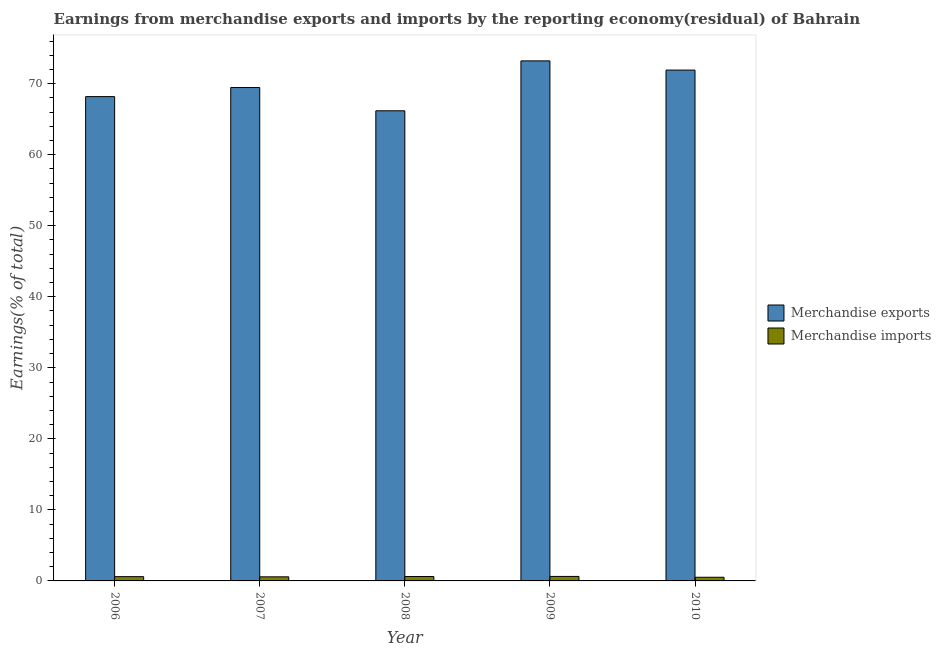How many different coloured bars are there?
Offer a terse response. 2. Are the number of bars on each tick of the X-axis equal?
Provide a succinct answer. Yes. How many bars are there on the 2nd tick from the left?
Provide a short and direct response. 2. In how many cases, is the number of bars for a given year not equal to the number of legend labels?
Your answer should be compact. 0. What is the earnings from merchandise imports in 2010?
Offer a very short reply. 0.52. Across all years, what is the maximum earnings from merchandise exports?
Offer a terse response. 73.21. Across all years, what is the minimum earnings from merchandise imports?
Your response must be concise. 0.52. In which year was the earnings from merchandise exports maximum?
Offer a terse response. 2009. What is the total earnings from merchandise exports in the graph?
Keep it short and to the point. 348.96. What is the difference between the earnings from merchandise imports in 2006 and that in 2009?
Offer a terse response. -0.03. What is the difference between the earnings from merchandise exports in 2006 and the earnings from merchandise imports in 2007?
Give a very brief answer. -1.28. What is the average earnings from merchandise exports per year?
Your answer should be very brief. 69.79. What is the ratio of the earnings from merchandise imports in 2008 to that in 2009?
Provide a short and direct response. 0.98. Is the difference between the earnings from merchandise imports in 2006 and 2007 greater than the difference between the earnings from merchandise exports in 2006 and 2007?
Offer a very short reply. No. What is the difference between the highest and the second highest earnings from merchandise imports?
Give a very brief answer. 0.01. What is the difference between the highest and the lowest earnings from merchandise imports?
Make the answer very short. 0.12. In how many years, is the earnings from merchandise imports greater than the average earnings from merchandise imports taken over all years?
Provide a short and direct response. 3. What does the 1st bar from the right in 2008 represents?
Keep it short and to the point. Merchandise imports. Are all the bars in the graph horizontal?
Ensure brevity in your answer.  No. Does the graph contain any zero values?
Make the answer very short. No. How are the legend labels stacked?
Give a very brief answer. Vertical. What is the title of the graph?
Your answer should be very brief. Earnings from merchandise exports and imports by the reporting economy(residual) of Bahrain. Does "Imports" appear as one of the legend labels in the graph?
Offer a very short reply. No. What is the label or title of the Y-axis?
Ensure brevity in your answer.  Earnings(% of total). What is the Earnings(% of total) of Merchandise exports in 2006?
Ensure brevity in your answer.  68.18. What is the Earnings(% of total) in Merchandise imports in 2006?
Offer a very short reply. 0.6. What is the Earnings(% of total) in Merchandise exports in 2007?
Offer a very short reply. 69.46. What is the Earnings(% of total) in Merchandise imports in 2007?
Ensure brevity in your answer.  0.58. What is the Earnings(% of total) in Merchandise exports in 2008?
Your answer should be compact. 66.19. What is the Earnings(% of total) of Merchandise imports in 2008?
Make the answer very short. 0.62. What is the Earnings(% of total) in Merchandise exports in 2009?
Make the answer very short. 73.21. What is the Earnings(% of total) in Merchandise imports in 2009?
Keep it short and to the point. 0.63. What is the Earnings(% of total) of Merchandise exports in 2010?
Offer a terse response. 71.92. What is the Earnings(% of total) of Merchandise imports in 2010?
Provide a succinct answer. 0.52. Across all years, what is the maximum Earnings(% of total) in Merchandise exports?
Make the answer very short. 73.21. Across all years, what is the maximum Earnings(% of total) in Merchandise imports?
Your answer should be very brief. 0.63. Across all years, what is the minimum Earnings(% of total) in Merchandise exports?
Your answer should be very brief. 66.19. Across all years, what is the minimum Earnings(% of total) of Merchandise imports?
Provide a succinct answer. 0.52. What is the total Earnings(% of total) in Merchandise exports in the graph?
Your answer should be compact. 348.96. What is the total Earnings(% of total) of Merchandise imports in the graph?
Offer a very short reply. 2.94. What is the difference between the Earnings(% of total) in Merchandise exports in 2006 and that in 2007?
Offer a terse response. -1.28. What is the difference between the Earnings(% of total) of Merchandise imports in 2006 and that in 2007?
Your answer should be compact. 0.03. What is the difference between the Earnings(% of total) in Merchandise exports in 2006 and that in 2008?
Your answer should be very brief. 2. What is the difference between the Earnings(% of total) of Merchandise imports in 2006 and that in 2008?
Offer a very short reply. -0.02. What is the difference between the Earnings(% of total) in Merchandise exports in 2006 and that in 2009?
Make the answer very short. -5.03. What is the difference between the Earnings(% of total) of Merchandise imports in 2006 and that in 2009?
Your answer should be compact. -0.03. What is the difference between the Earnings(% of total) in Merchandise exports in 2006 and that in 2010?
Give a very brief answer. -3.74. What is the difference between the Earnings(% of total) of Merchandise imports in 2006 and that in 2010?
Your answer should be compact. 0.09. What is the difference between the Earnings(% of total) in Merchandise exports in 2007 and that in 2008?
Offer a very short reply. 3.27. What is the difference between the Earnings(% of total) in Merchandise imports in 2007 and that in 2008?
Offer a very short reply. -0.04. What is the difference between the Earnings(% of total) in Merchandise exports in 2007 and that in 2009?
Ensure brevity in your answer.  -3.75. What is the difference between the Earnings(% of total) of Merchandise imports in 2007 and that in 2009?
Ensure brevity in your answer.  -0.06. What is the difference between the Earnings(% of total) of Merchandise exports in 2007 and that in 2010?
Provide a succinct answer. -2.46. What is the difference between the Earnings(% of total) in Merchandise imports in 2007 and that in 2010?
Offer a terse response. 0.06. What is the difference between the Earnings(% of total) in Merchandise exports in 2008 and that in 2009?
Provide a succinct answer. -7.03. What is the difference between the Earnings(% of total) of Merchandise imports in 2008 and that in 2009?
Provide a short and direct response. -0.01. What is the difference between the Earnings(% of total) of Merchandise exports in 2008 and that in 2010?
Your response must be concise. -5.73. What is the difference between the Earnings(% of total) of Merchandise imports in 2008 and that in 2010?
Keep it short and to the point. 0.1. What is the difference between the Earnings(% of total) of Merchandise exports in 2009 and that in 2010?
Offer a terse response. 1.3. What is the difference between the Earnings(% of total) in Merchandise imports in 2009 and that in 2010?
Provide a short and direct response. 0.12. What is the difference between the Earnings(% of total) in Merchandise exports in 2006 and the Earnings(% of total) in Merchandise imports in 2007?
Provide a succinct answer. 67.61. What is the difference between the Earnings(% of total) of Merchandise exports in 2006 and the Earnings(% of total) of Merchandise imports in 2008?
Offer a very short reply. 67.56. What is the difference between the Earnings(% of total) in Merchandise exports in 2006 and the Earnings(% of total) in Merchandise imports in 2009?
Offer a very short reply. 67.55. What is the difference between the Earnings(% of total) in Merchandise exports in 2006 and the Earnings(% of total) in Merchandise imports in 2010?
Your answer should be compact. 67.67. What is the difference between the Earnings(% of total) in Merchandise exports in 2007 and the Earnings(% of total) in Merchandise imports in 2008?
Your answer should be very brief. 68.84. What is the difference between the Earnings(% of total) in Merchandise exports in 2007 and the Earnings(% of total) in Merchandise imports in 2009?
Your response must be concise. 68.83. What is the difference between the Earnings(% of total) of Merchandise exports in 2007 and the Earnings(% of total) of Merchandise imports in 2010?
Ensure brevity in your answer.  68.94. What is the difference between the Earnings(% of total) in Merchandise exports in 2008 and the Earnings(% of total) in Merchandise imports in 2009?
Your response must be concise. 65.55. What is the difference between the Earnings(% of total) in Merchandise exports in 2008 and the Earnings(% of total) in Merchandise imports in 2010?
Give a very brief answer. 65.67. What is the difference between the Earnings(% of total) of Merchandise exports in 2009 and the Earnings(% of total) of Merchandise imports in 2010?
Offer a terse response. 72.7. What is the average Earnings(% of total) in Merchandise exports per year?
Your response must be concise. 69.79. What is the average Earnings(% of total) of Merchandise imports per year?
Make the answer very short. 0.59. In the year 2006, what is the difference between the Earnings(% of total) of Merchandise exports and Earnings(% of total) of Merchandise imports?
Keep it short and to the point. 67.58. In the year 2007, what is the difference between the Earnings(% of total) of Merchandise exports and Earnings(% of total) of Merchandise imports?
Keep it short and to the point. 68.88. In the year 2008, what is the difference between the Earnings(% of total) of Merchandise exports and Earnings(% of total) of Merchandise imports?
Your answer should be compact. 65.57. In the year 2009, what is the difference between the Earnings(% of total) in Merchandise exports and Earnings(% of total) in Merchandise imports?
Provide a succinct answer. 72.58. In the year 2010, what is the difference between the Earnings(% of total) of Merchandise exports and Earnings(% of total) of Merchandise imports?
Make the answer very short. 71.4. What is the ratio of the Earnings(% of total) in Merchandise exports in 2006 to that in 2007?
Provide a short and direct response. 0.98. What is the ratio of the Earnings(% of total) of Merchandise imports in 2006 to that in 2007?
Make the answer very short. 1.04. What is the ratio of the Earnings(% of total) in Merchandise exports in 2006 to that in 2008?
Your answer should be very brief. 1.03. What is the ratio of the Earnings(% of total) in Merchandise imports in 2006 to that in 2008?
Ensure brevity in your answer.  0.97. What is the ratio of the Earnings(% of total) in Merchandise exports in 2006 to that in 2009?
Offer a very short reply. 0.93. What is the ratio of the Earnings(% of total) of Merchandise imports in 2006 to that in 2009?
Your response must be concise. 0.95. What is the ratio of the Earnings(% of total) of Merchandise exports in 2006 to that in 2010?
Offer a very short reply. 0.95. What is the ratio of the Earnings(% of total) in Merchandise imports in 2006 to that in 2010?
Keep it short and to the point. 1.17. What is the ratio of the Earnings(% of total) of Merchandise exports in 2007 to that in 2008?
Your response must be concise. 1.05. What is the ratio of the Earnings(% of total) in Merchandise imports in 2007 to that in 2008?
Your response must be concise. 0.93. What is the ratio of the Earnings(% of total) in Merchandise exports in 2007 to that in 2009?
Offer a terse response. 0.95. What is the ratio of the Earnings(% of total) in Merchandise imports in 2007 to that in 2009?
Ensure brevity in your answer.  0.91. What is the ratio of the Earnings(% of total) in Merchandise exports in 2007 to that in 2010?
Your answer should be very brief. 0.97. What is the ratio of the Earnings(% of total) in Merchandise imports in 2007 to that in 2010?
Give a very brief answer. 1.12. What is the ratio of the Earnings(% of total) of Merchandise exports in 2008 to that in 2009?
Make the answer very short. 0.9. What is the ratio of the Earnings(% of total) of Merchandise imports in 2008 to that in 2009?
Keep it short and to the point. 0.98. What is the ratio of the Earnings(% of total) of Merchandise exports in 2008 to that in 2010?
Offer a very short reply. 0.92. What is the ratio of the Earnings(% of total) of Merchandise imports in 2008 to that in 2010?
Your answer should be compact. 1.2. What is the ratio of the Earnings(% of total) of Merchandise exports in 2009 to that in 2010?
Your answer should be compact. 1.02. What is the ratio of the Earnings(% of total) of Merchandise imports in 2009 to that in 2010?
Offer a terse response. 1.23. What is the difference between the highest and the second highest Earnings(% of total) in Merchandise exports?
Offer a very short reply. 1.3. What is the difference between the highest and the second highest Earnings(% of total) in Merchandise imports?
Your answer should be compact. 0.01. What is the difference between the highest and the lowest Earnings(% of total) of Merchandise exports?
Ensure brevity in your answer.  7.03. What is the difference between the highest and the lowest Earnings(% of total) of Merchandise imports?
Ensure brevity in your answer.  0.12. 